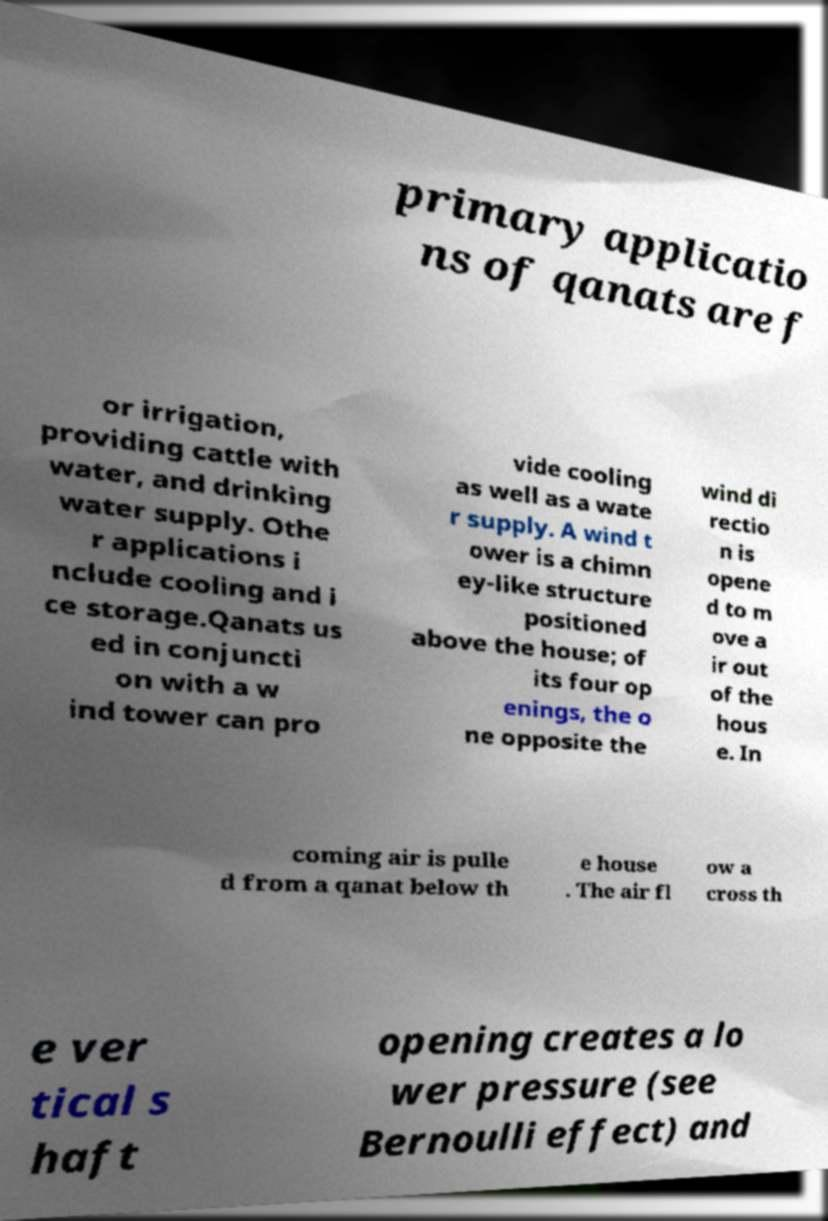Please identify and transcribe the text found in this image. primary applicatio ns of qanats are f or irrigation, providing cattle with water, and drinking water supply. Othe r applications i nclude cooling and i ce storage.Qanats us ed in conjuncti on with a w ind tower can pro vide cooling as well as a wate r supply. A wind t ower is a chimn ey-like structure positioned above the house; of its four op enings, the o ne opposite the wind di rectio n is opene d to m ove a ir out of the hous e. In coming air is pulle d from a qanat below th e house . The air fl ow a cross th e ver tical s haft opening creates a lo wer pressure (see Bernoulli effect) and 